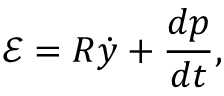<formula> <loc_0><loc_0><loc_500><loc_500>\mathcal { E } = R \dot { y } + \frac { d p } { d t } ,</formula> 